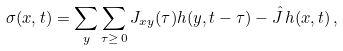Convert formula to latex. <formula><loc_0><loc_0><loc_500><loc_500>\sigma ( { x } , t ) = \sum _ { y } \sum _ { \tau \geq \, 0 } J _ { { x } { y } } ( \tau ) h ( { y } , t - \tau ) - \hat { J } \, h ( { x } , t ) \, ,</formula> 